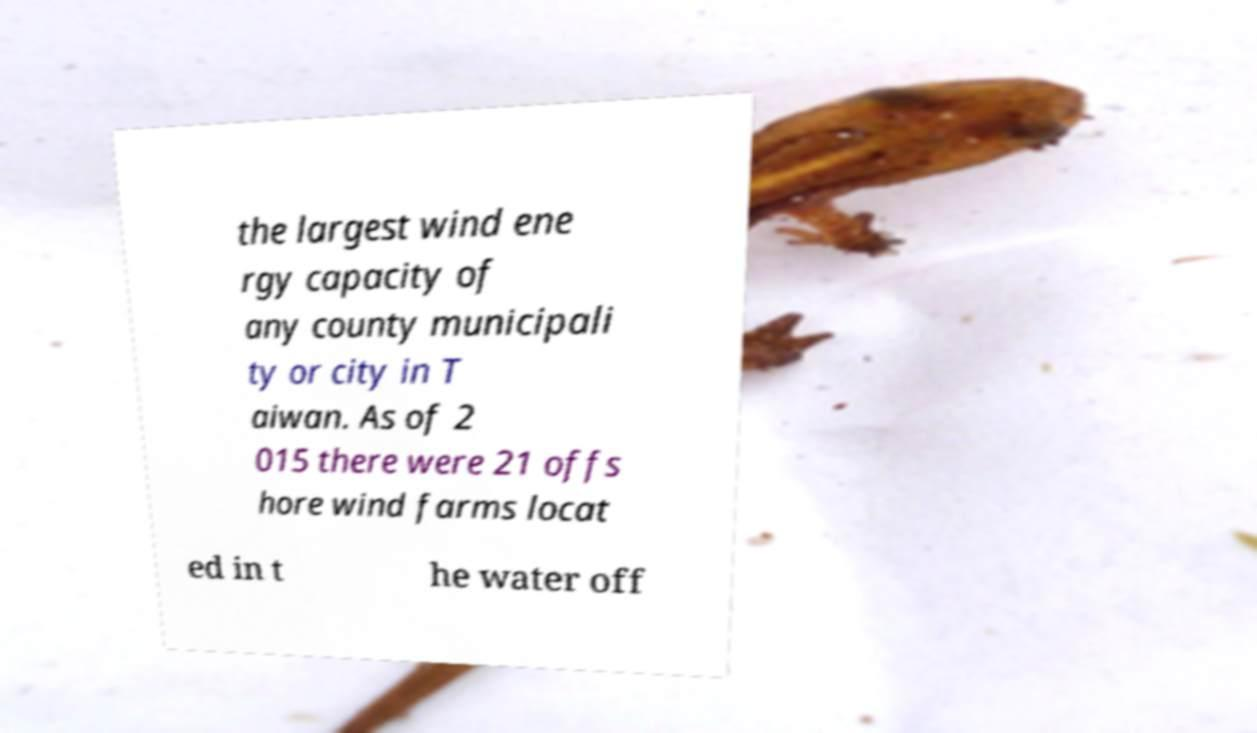What messages or text are displayed in this image? I need them in a readable, typed format. the largest wind ene rgy capacity of any county municipali ty or city in T aiwan. As of 2 015 there were 21 offs hore wind farms locat ed in t he water off 